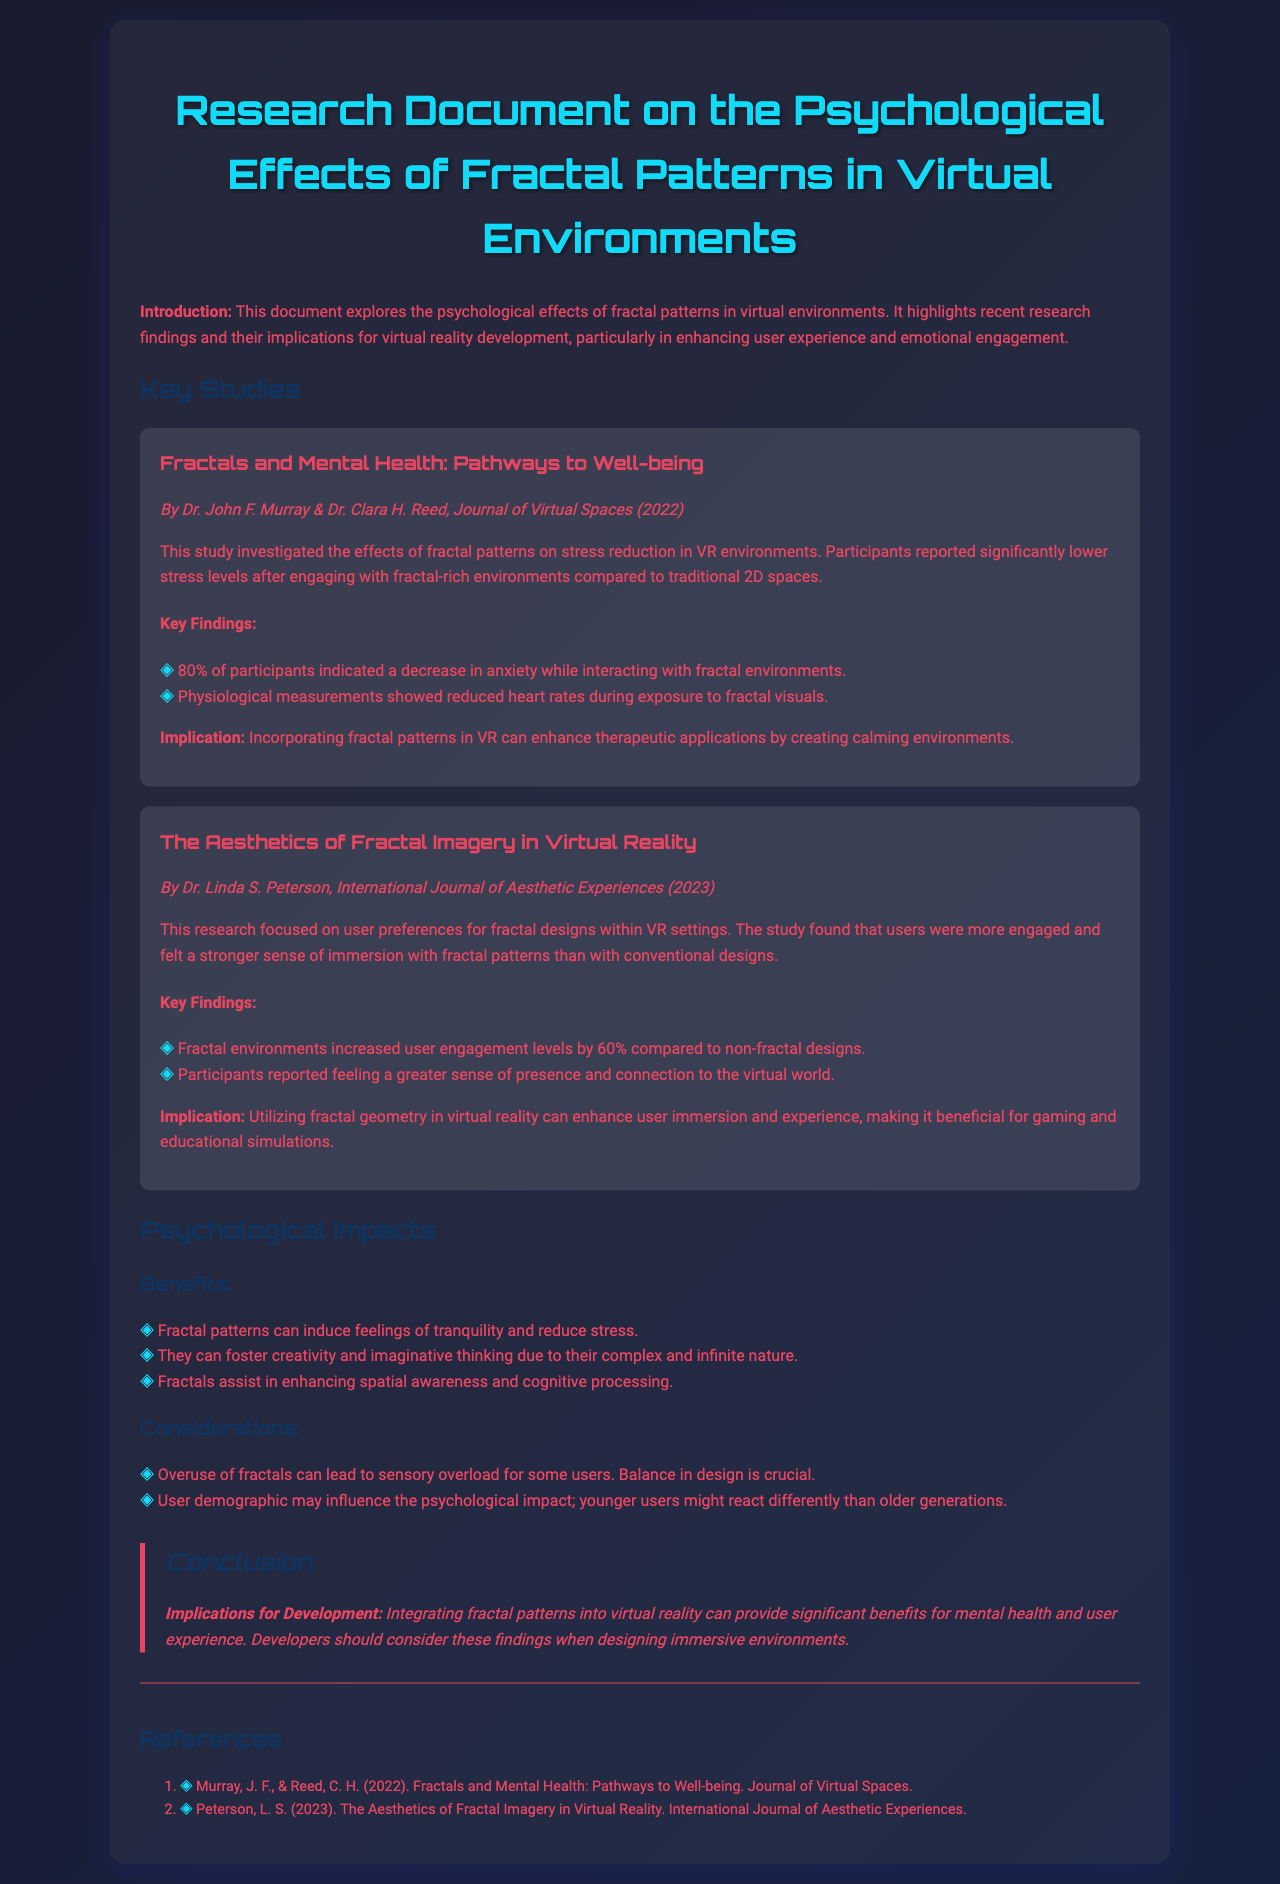what is the title of the document? The title of the document is provided at the top of the document in a prominent header.
Answer: Research Document on the Psychological Effects of Fractal Patterns in Virtual Environments who conducted the study on stress reduction in VR environments? The authors of this study are mentioned in the section describing the first key study, attributing the work to them.
Answer: Dr. John F. Murray & Dr. Clara H. Reed what percentage of participants indicated a decrease in anxiety with fractal environments? The percentage is stated as part of the key findings in the first study regarding fractals and mental health.
Answer: 80% how much did user engagement levels increase with fractal environments compared to non-fractal designs? The increase in user engagement levels is specified in the findings of the second study about fractal imagery.
Answer: 60% what are the benefits of fractal patterns listed in the document? The document lists specific psychological benefits of fractal patterns in the section discussing their impacts.
Answer: Tranquility, creativity, spatial awareness what is a consideration mentioned regarding the use of fractals in design? The document provides considerations about the potential drawbacks or challenges when using fractals in virtual environments.
Answer: Sensory overload what is the primary implication for developers mentioned in the conclusion? The conclusion summarizes the key takeaway for developers considering fractal patterns in their work.
Answer: Mental health and user experience who wrote the research on the aesthetics of fractal imagery in VR? The author of the second key study is mentioned at the beginning of that specific study section.
Answer: Dr. Linda S. Peterson 